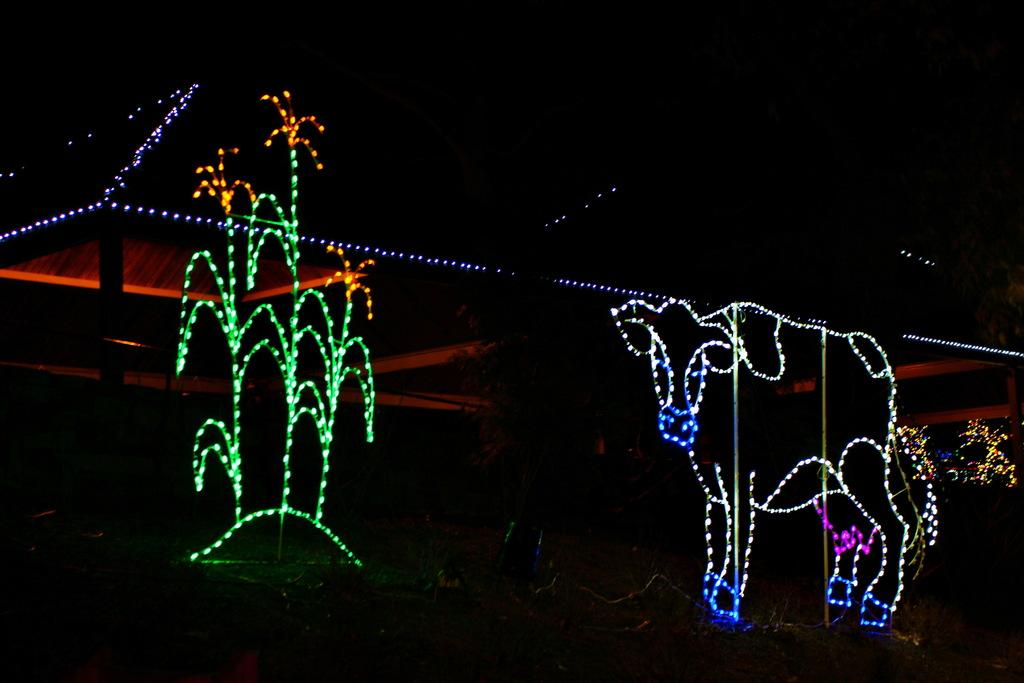Can you describe the background of the image? There might be a building in the background of the image. What type of lighting fixtures are present in the image? The lighting fixtures are in the form of a tree and an animal. Where is the crayon located in the image? There is no crayon present in the image. What type of arch can be seen in the image? There is no arch present in the image. 